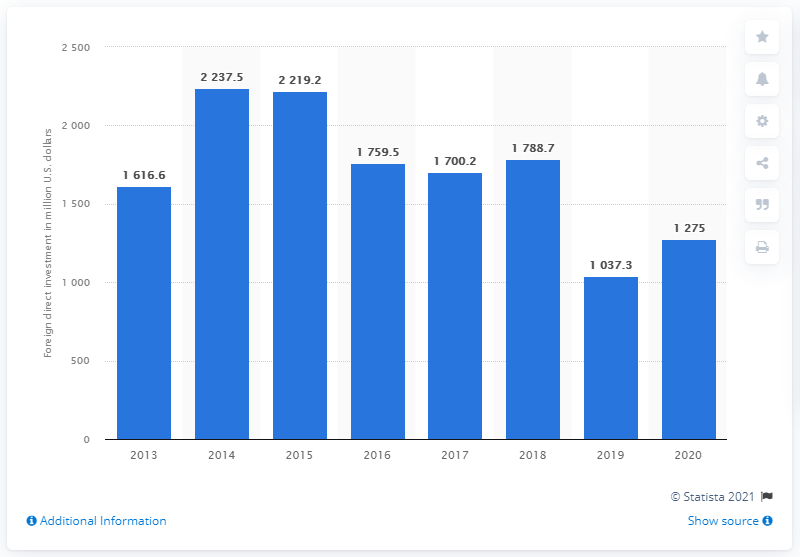List a handful of essential elements in this visual. In 2020, the amount of foreign direct investment in agriculture, hunting, forestry, and fishery totaled 1275. 